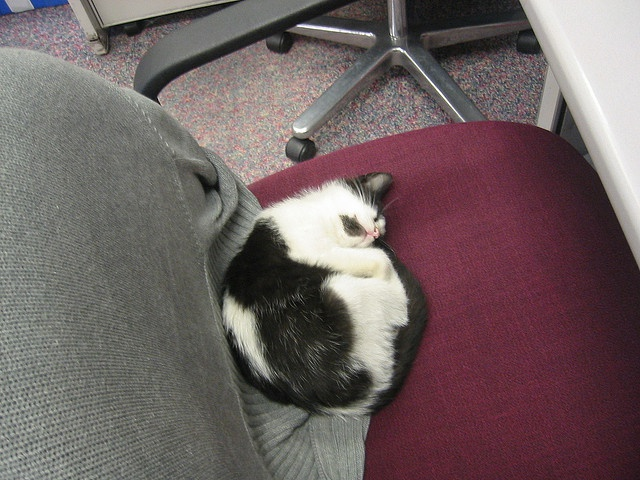Describe the objects in this image and their specific colors. I can see chair in darkblue, gray, maroon, and brown tones, cat in darkblue, black, ivory, gray, and darkgray tones, and chair in darkblue, gray, and black tones in this image. 